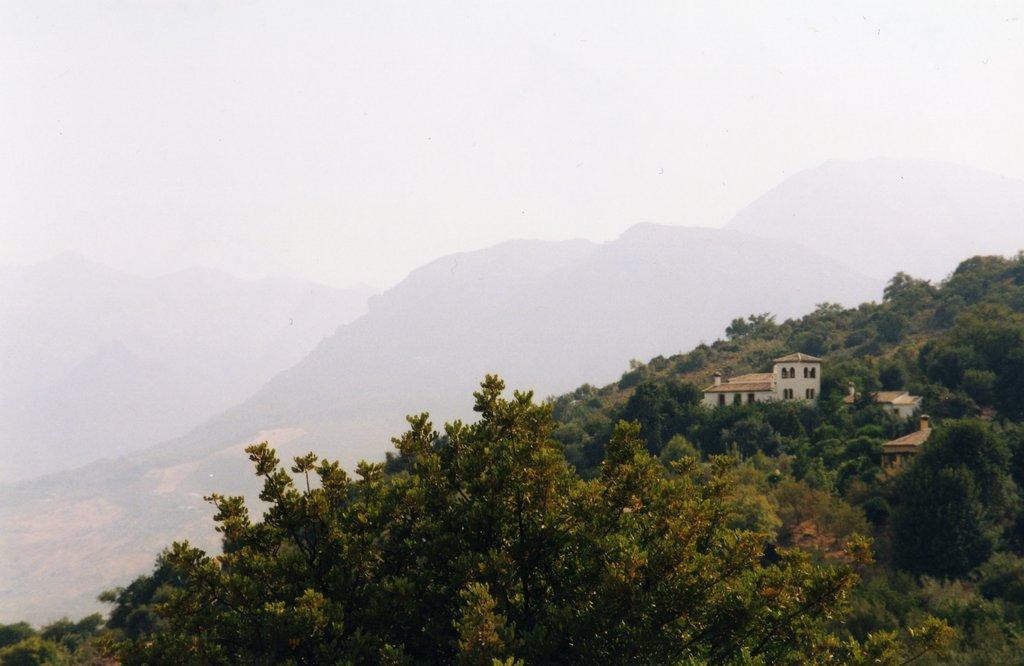How would you summarize this image in a sentence or two? In this image I can see many trees. To the right I can see the houses. In the background I can see the mountains and the sky. 